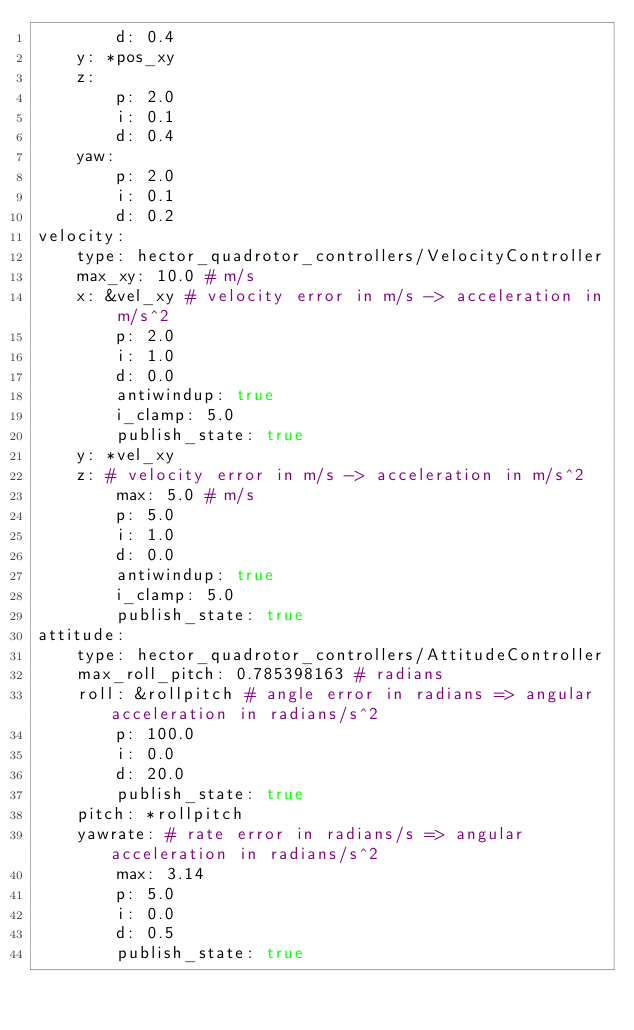<code> <loc_0><loc_0><loc_500><loc_500><_YAML_>        d: 0.4
    y: *pos_xy
    z:
        p: 2.0
        i: 0.1
        d: 0.4
    yaw:
        p: 2.0
        i: 0.1
        d: 0.2
velocity:
    type: hector_quadrotor_controllers/VelocityController
    max_xy: 10.0 # m/s
    x: &vel_xy # velocity error in m/s -> acceleration in m/s^2
        p: 2.0
        i: 1.0
        d: 0.0
        antiwindup: true
        i_clamp: 5.0
        publish_state: true
    y: *vel_xy
    z: # velocity error in m/s -> acceleration in m/s^2
        max: 5.0 # m/s
        p: 5.0
        i: 1.0
        d: 0.0
        antiwindup: true
        i_clamp: 5.0
        publish_state: true
attitude:
    type: hector_quadrotor_controllers/AttitudeController
    max_roll_pitch: 0.785398163 # radians
    roll: &rollpitch # angle error in radians => angular acceleration in radians/s^2
        p: 100.0
        i: 0.0
        d: 20.0
        publish_state: true
    pitch: *rollpitch
    yawrate: # rate error in radians/s => angular acceleration in radians/s^2
        max: 3.14
        p: 5.0
        i: 0.0
        d: 0.5
        publish_state: true
</code> 